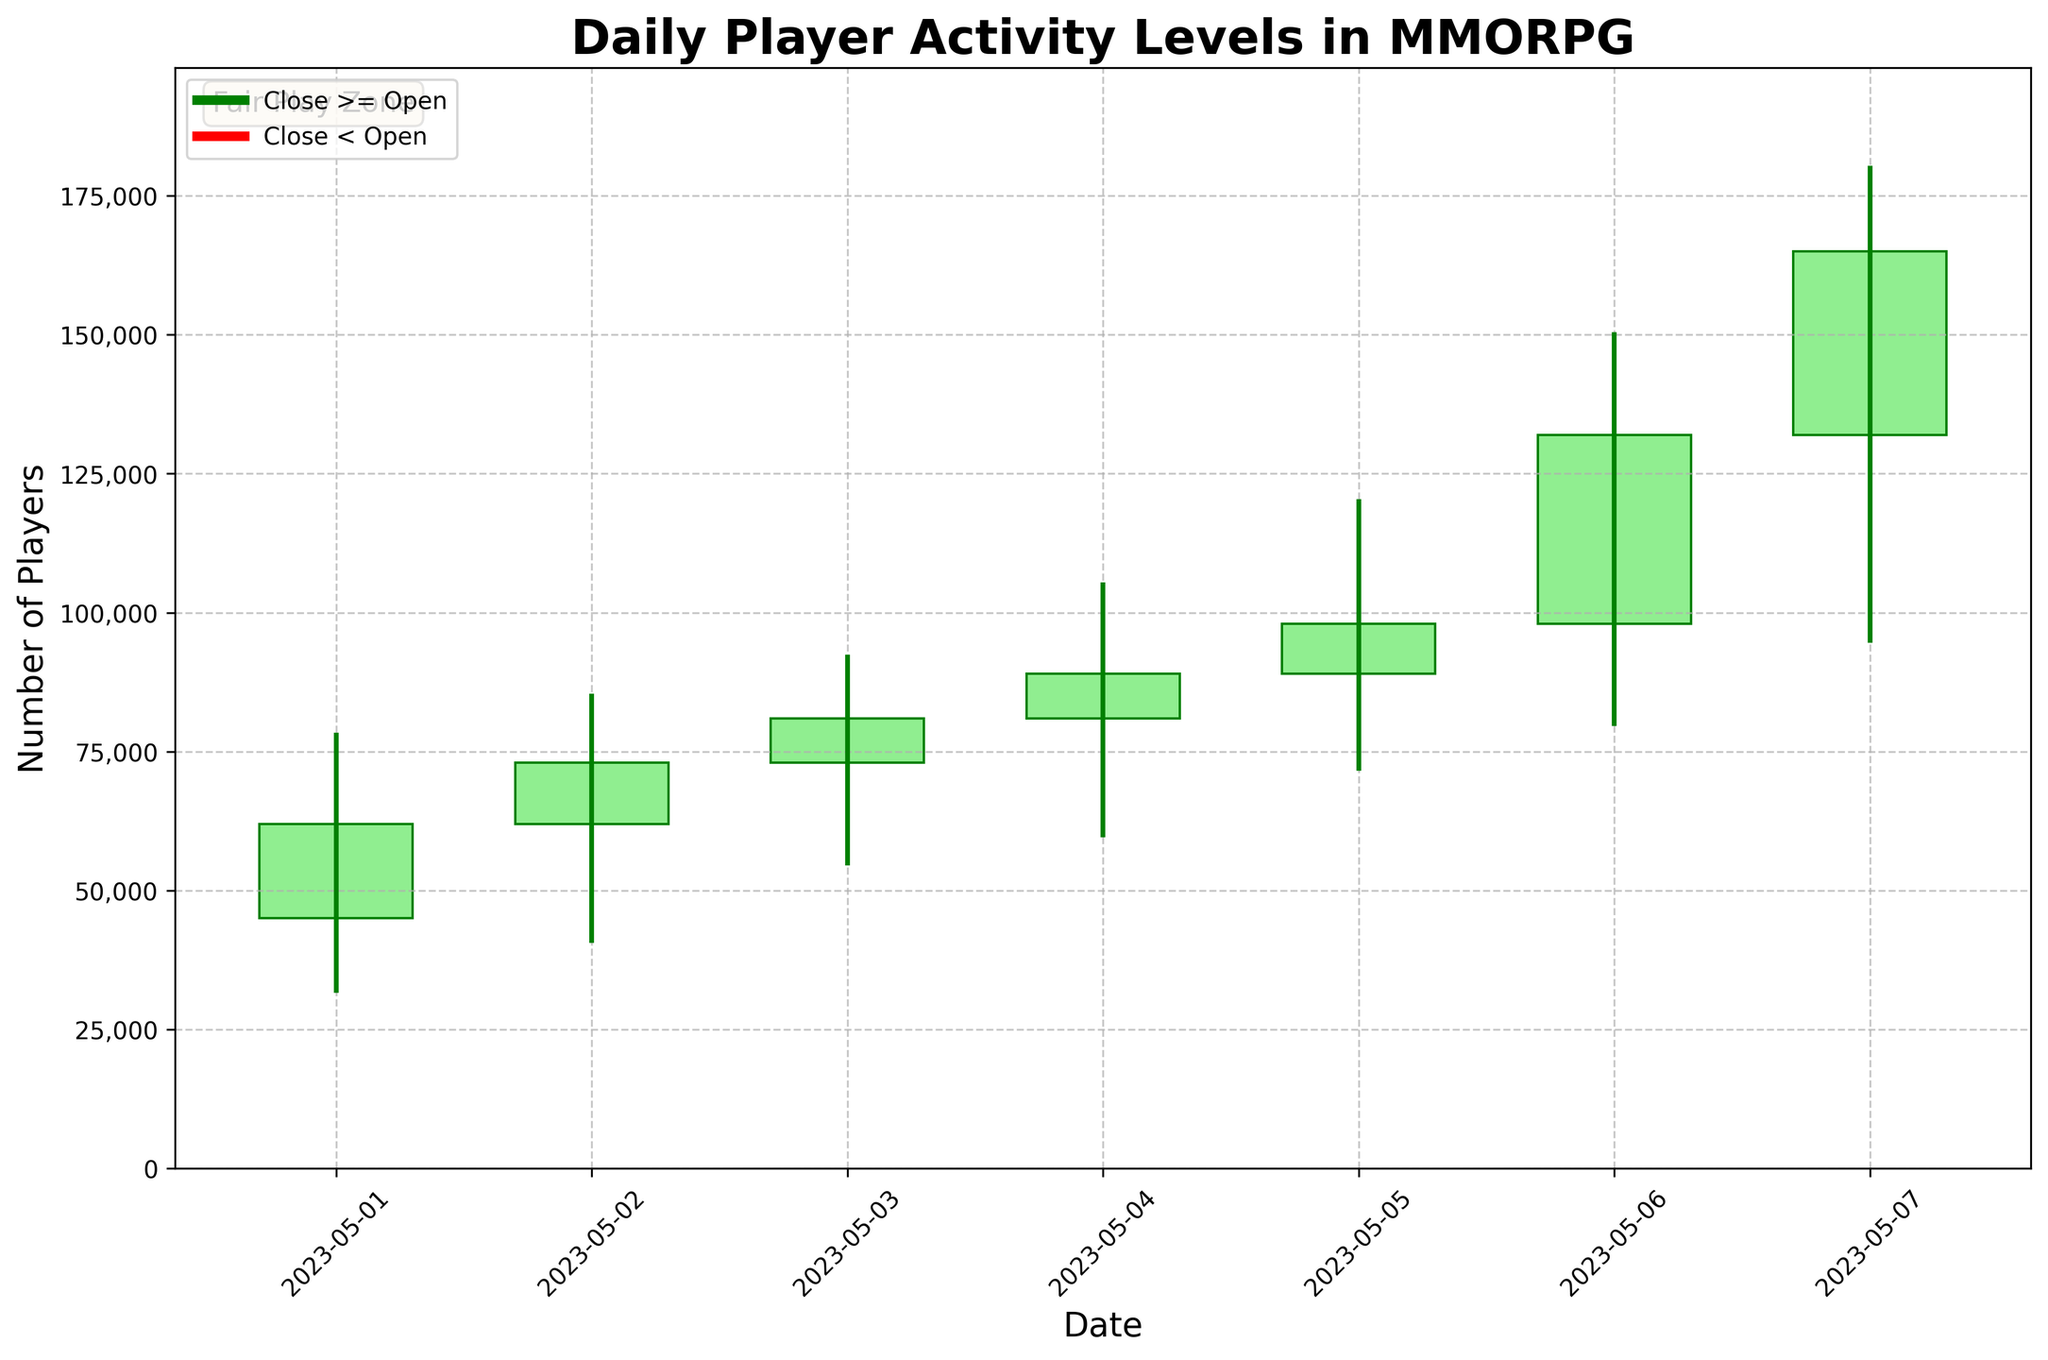what is the title of the plot? The title is displayed at the top of the chart and provides an overview of what the plot represents. They are usually presented in bold with larger font sizes.
Answer: Daily Player Activity Levels in MMORPG How many data points are displayed in the chart? Each candlestick represents a day of data. We can count the number of candlesticks to find the answer.
Answer: 7 Which date shows the highest peak player activity? The peak player activity corresponds to the highest value in the 'High' column. We can identify which date has the tallest wick, representing the highest point.
Answer: 2023-05-07 On which date did the number of players decrease compared to the opening value? A decrease in player count is shown by a red candlestick. We identify the date(s) with red-colored candlesticks in the plot.
Answer: None What is the range of player activity on 2023-05-06? The range of player activity is the difference between the highest and lowest values (High - Low) for that date. For 2023-05-06, it is calculated as 150,000 - 80,000.
Answer: 70,000 Which day had the lowest starting player count? The starting player count for each day is represented by the 'Open' value of the candlesticks. We look for the smallest 'Open' value.
Answer: 2023-05-01 Between 2023-05-03 and 2023-05-05, which day had the highest closing value? We compare the 'Close' values for the specified dates and identify the highest one.
Answer: 2023-05-05 What is the cumulative sum of the closing values from 2023-05-01 to 2023-05-07? To find the cumulative sum, we add up all the 'Close' values from each date. The values are: 62,000 + 73,000 + 81,000 + 89,000 + 98,000 + 132,000 + 165,000.
Answer: 700,000 Which days show the highest increase in player activity? We look for days with significant differences between the 'Open' and 'Close' values, and larger positive differences indicate higher increases.
Answer: 2023-05-06, 2023-05-07 